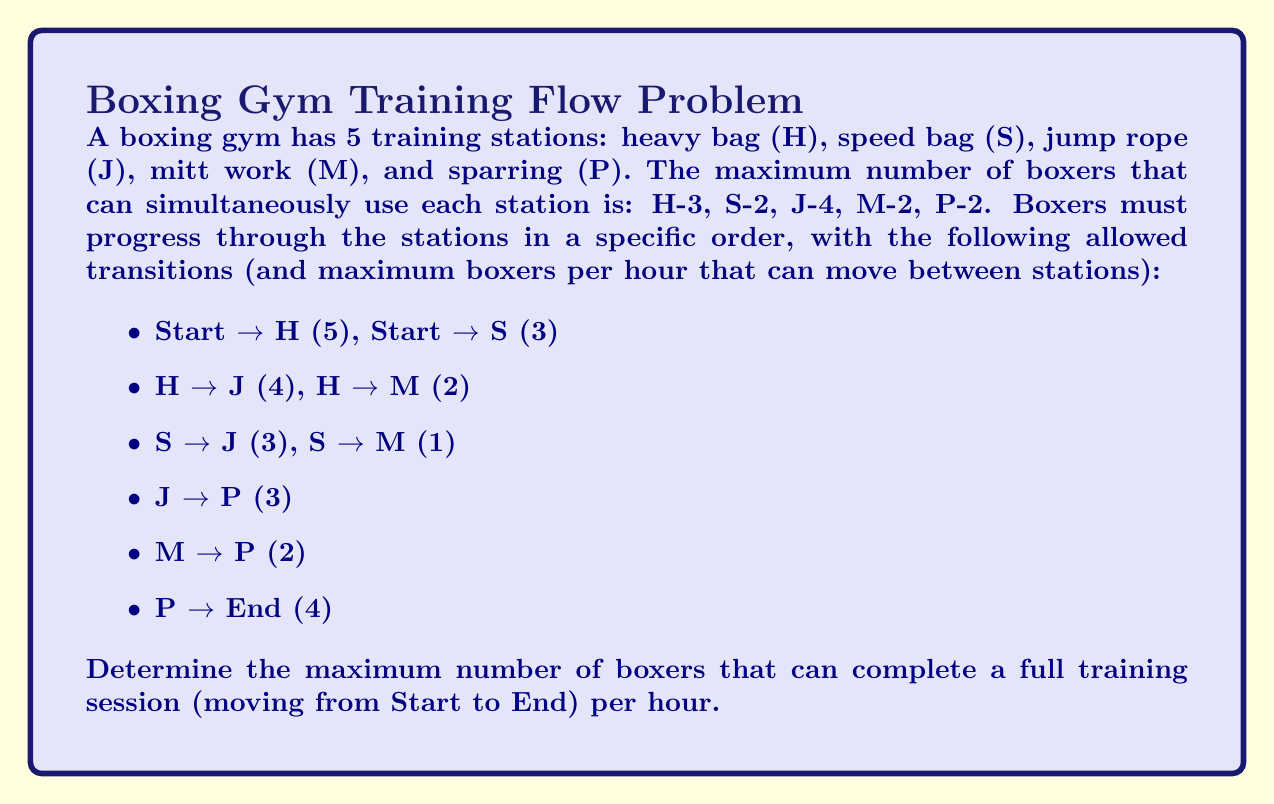Can you answer this question? To solve this problem, we can use the Ford-Fulkerson algorithm to find the maximum flow in the network. Let's approach this step-by-step:

1) First, we need to construct a flow network. The nodes are Start, H, S, J, M, P, and End. The edges are the allowed transitions with their capacities.

2) We'll use the Ford-Fulkerson algorithm to find augmenting paths from Start to End until no more paths exist.

3) Augmenting Path 1: Start → H → J → P → End
   Flow: min(5, 4, 3, 4) = 3
   Remaining capacities: Start → H (2), H → J (1), J → P (0), P → End (1)

4) Augmenting Path 2: Start → S → J → P → End
   Flow: min(3, 3, 0, 1) = 0
   No flow can be pushed through this path due to J → P being saturated.

5) Augmenting Path 3: Start → H → M → P → End
   Flow: min(2, 2, 2, 1) = 1
   Remaining capacities: Start → H (1), H → M (1), M → P (1), P → End (0)

6) Augmenting Path 4: Start → S → M → P → End
   Flow: min(3, 1, 1, 0) = 0
   No flow can be pushed through this path due to P → End being saturated.

7) No more augmenting paths exist.

The maximum flow is the sum of the flows we pushed through the network: 3 + 1 = 4.

This result can be verified by examining the flow out of the Start node (4) or into the End node (4).
Answer: The maximum number of boxers that can complete a full training session per hour is 4. 